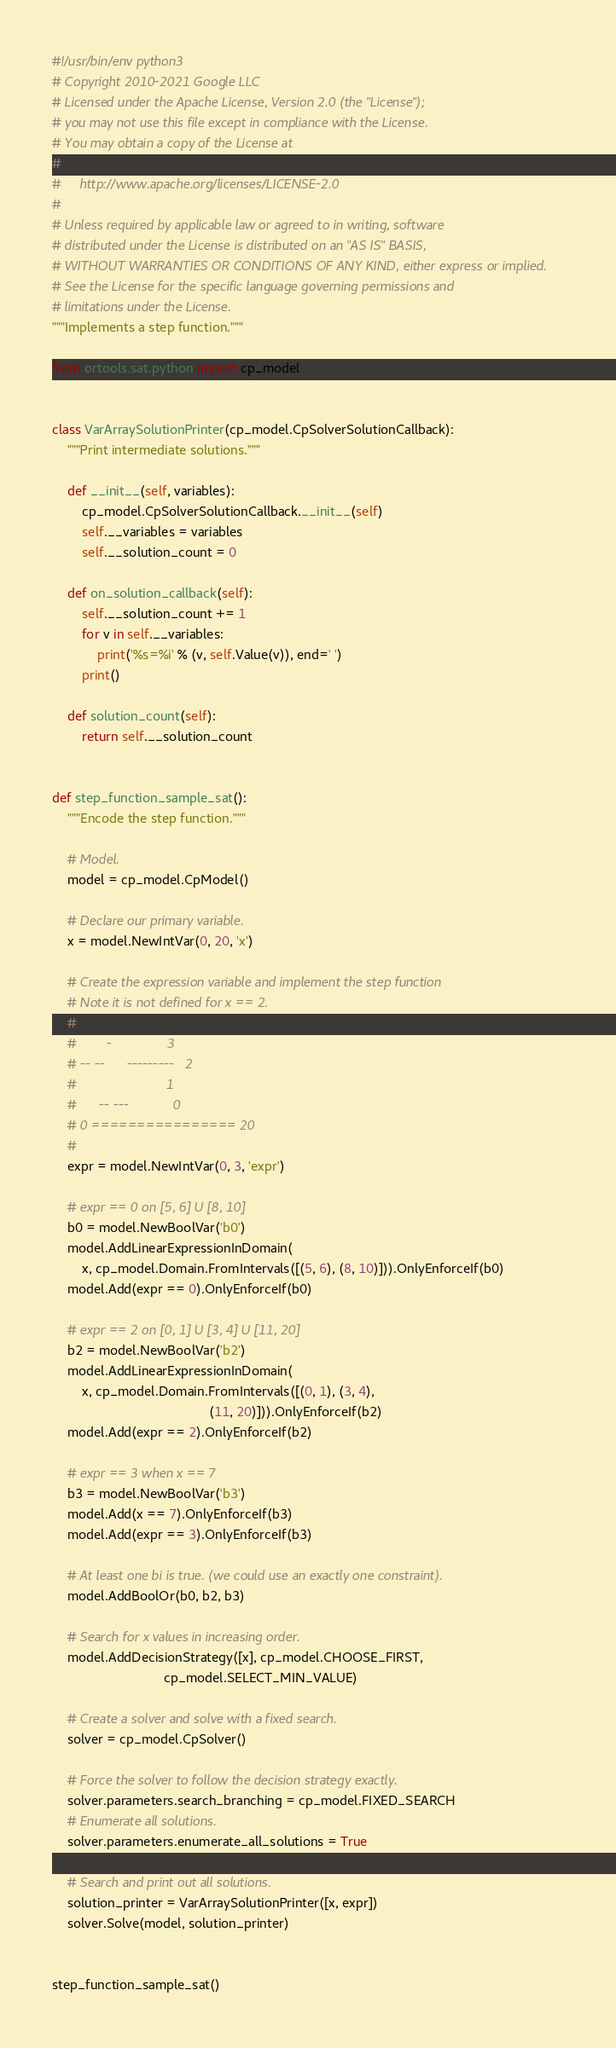<code> <loc_0><loc_0><loc_500><loc_500><_Python_>#!/usr/bin/env python3
# Copyright 2010-2021 Google LLC
# Licensed under the Apache License, Version 2.0 (the "License");
# you may not use this file except in compliance with the License.
# You may obtain a copy of the License at
#
#     http://www.apache.org/licenses/LICENSE-2.0
#
# Unless required by applicable law or agreed to in writing, software
# distributed under the License is distributed on an "AS IS" BASIS,
# WITHOUT WARRANTIES OR CONDITIONS OF ANY KIND, either express or implied.
# See the License for the specific language governing permissions and
# limitations under the License.
"""Implements a step function."""

from ortools.sat.python import cp_model


class VarArraySolutionPrinter(cp_model.CpSolverSolutionCallback):
    """Print intermediate solutions."""

    def __init__(self, variables):
        cp_model.CpSolverSolutionCallback.__init__(self)
        self.__variables = variables
        self.__solution_count = 0

    def on_solution_callback(self):
        self.__solution_count += 1
        for v in self.__variables:
            print('%s=%i' % (v, self.Value(v)), end=' ')
        print()

    def solution_count(self):
        return self.__solution_count


def step_function_sample_sat():
    """Encode the step function."""

    # Model.
    model = cp_model.CpModel()

    # Declare our primary variable.
    x = model.NewIntVar(0, 20, 'x')

    # Create the expression variable and implement the step function
    # Note it is not defined for x == 2.
    #
    #        -               3
    # -- --      ---------   2
    #                        1
    #      -- ---            0
    # 0 ================ 20
    #
    expr = model.NewIntVar(0, 3, 'expr')

    # expr == 0 on [5, 6] U [8, 10]
    b0 = model.NewBoolVar('b0')
    model.AddLinearExpressionInDomain(
        x, cp_model.Domain.FromIntervals([(5, 6), (8, 10)])).OnlyEnforceIf(b0)
    model.Add(expr == 0).OnlyEnforceIf(b0)

    # expr == 2 on [0, 1] U [3, 4] U [11, 20]
    b2 = model.NewBoolVar('b2')
    model.AddLinearExpressionInDomain(
        x, cp_model.Domain.FromIntervals([(0, 1), (3, 4),
                                          (11, 20)])).OnlyEnforceIf(b2)
    model.Add(expr == 2).OnlyEnforceIf(b2)

    # expr == 3 when x == 7
    b3 = model.NewBoolVar('b3')
    model.Add(x == 7).OnlyEnforceIf(b3)
    model.Add(expr == 3).OnlyEnforceIf(b3)

    # At least one bi is true. (we could use an exactly one constraint).
    model.AddBoolOr(b0, b2, b3)

    # Search for x values in increasing order.
    model.AddDecisionStrategy([x], cp_model.CHOOSE_FIRST,
                              cp_model.SELECT_MIN_VALUE)

    # Create a solver and solve with a fixed search.
    solver = cp_model.CpSolver()

    # Force the solver to follow the decision strategy exactly.
    solver.parameters.search_branching = cp_model.FIXED_SEARCH
    # Enumerate all solutions.
    solver.parameters.enumerate_all_solutions = True

    # Search and print out all solutions.
    solution_printer = VarArraySolutionPrinter([x, expr])
    solver.Solve(model, solution_printer)


step_function_sample_sat()
</code> 